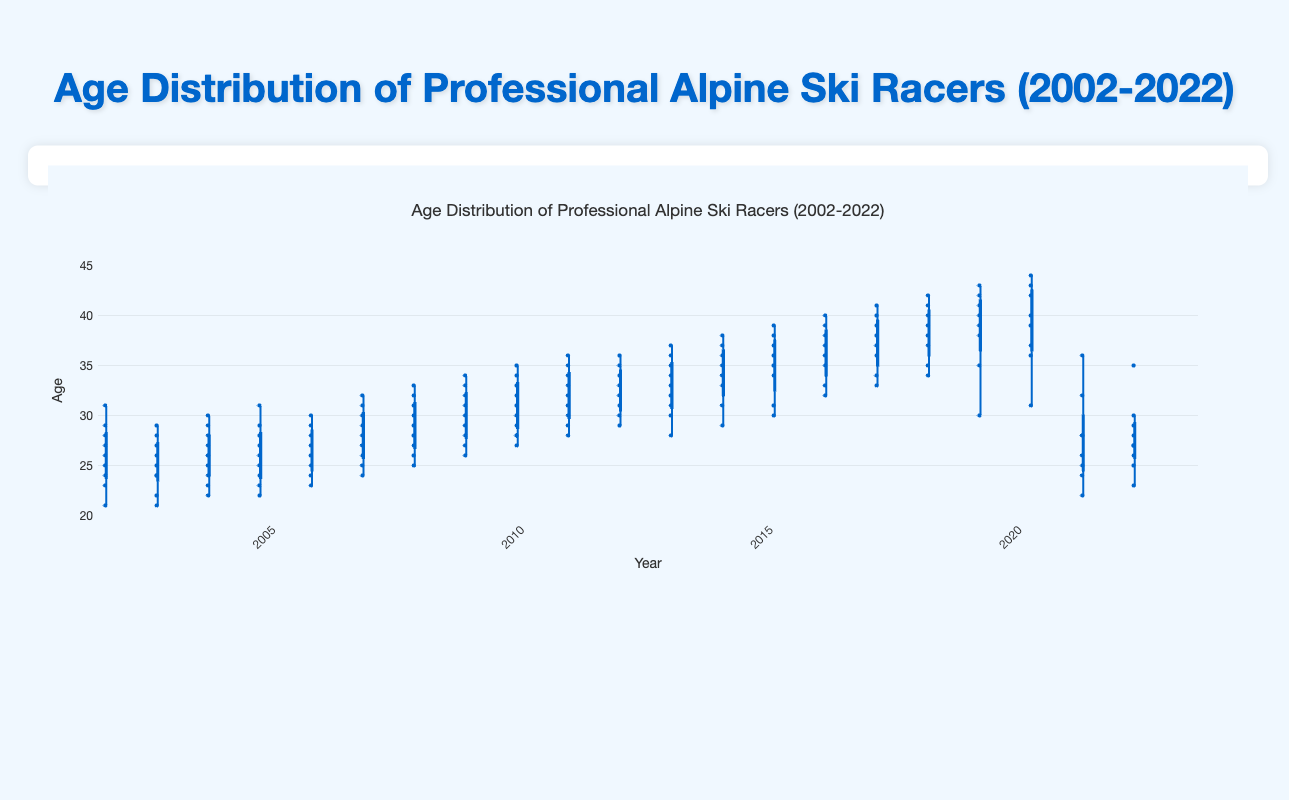What's the title of the plot? The title is usually displayed at the top of the plot in a larger or bold font. In this case, it clearly states the subject of the plot.
Answer: Age Distribution of Professional Alpine Ski Racers (2002-2022) What is the range of ages shown on the y-axis? The y-axis range is given in the plot, starting from the minimum value to the maximum value. In this case, it ranges from 20 to 45.
Answer: 20 to 45 For which year is the median age the highest? By examining the central line inside the boxes for each year, we can identify the highest median value.
Answer: 2020 Which year has the smallest interquartile range (IQR)? The IQR is the range between the first quartile (bottom of the box) and the third quartile (top of the box). We look for the year where the height of the box is the smallest.
Answer: 2002 In which year did the youngest ski racer participate? We can identify the youngest racer by finding the data point that falls at the lowest end of the distribution in each year. In this plot, the youngest racer participated in 2002.
Answer: 2002 How does the median age change from 2002 to 2022? By comparing the median lines from 2002 to 2022, we can observe the trend. The median age increases gradually over time.
Answer: It increases What were the ages at the maximum outlier values in 2019? Outliers are points that lie beyond the whiskers of the box in a box plot. By looking at the highest points for 2019, the ages are 41, 42, and 43.
Answer: 41, 42, 43 Which year has the widest age distribution? The year with the longest distance from the bottom whisker to the top whisker represents the widest age distribution. In this plot, 2020 has a wide distribution.
Answer: 2020 How many years feature an age distribution where the lower quartile is below 27 years? We count the boxes where the bottom edge (lower quartile) is below the age of 27.
Answer: Four years (2002, 2003, 2004, 2005) Which year shows the least amount of age variability? Age variability can be inferred from the width of the boxes and the length of the whiskers. The year with the smallest range between the whiskers and the smallest box is 2002.
Answer: 2002 